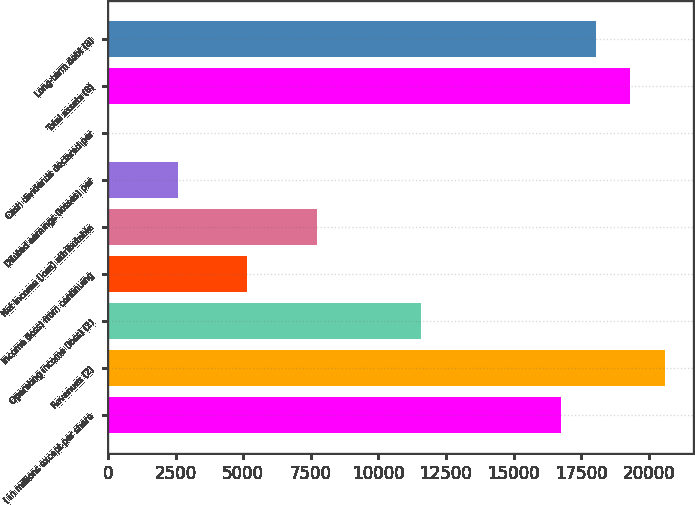<chart> <loc_0><loc_0><loc_500><loc_500><bar_chart><fcel>( in millions except per share<fcel>Revenues (2)<fcel>Operating income (loss) (2)<fcel>Income (loss) from continuing<fcel>Net income (loss) attributable<fcel>Diluted earnings (losses) per<fcel>Cash dividends declared per<fcel>Total assets (8)<fcel>Long-term debt (8)<nl><fcel>16742.6<fcel>20606.2<fcel>11591.2<fcel>5151.81<fcel>7727.55<fcel>2576.07<fcel>0.33<fcel>19318.4<fcel>18030.5<nl></chart> 